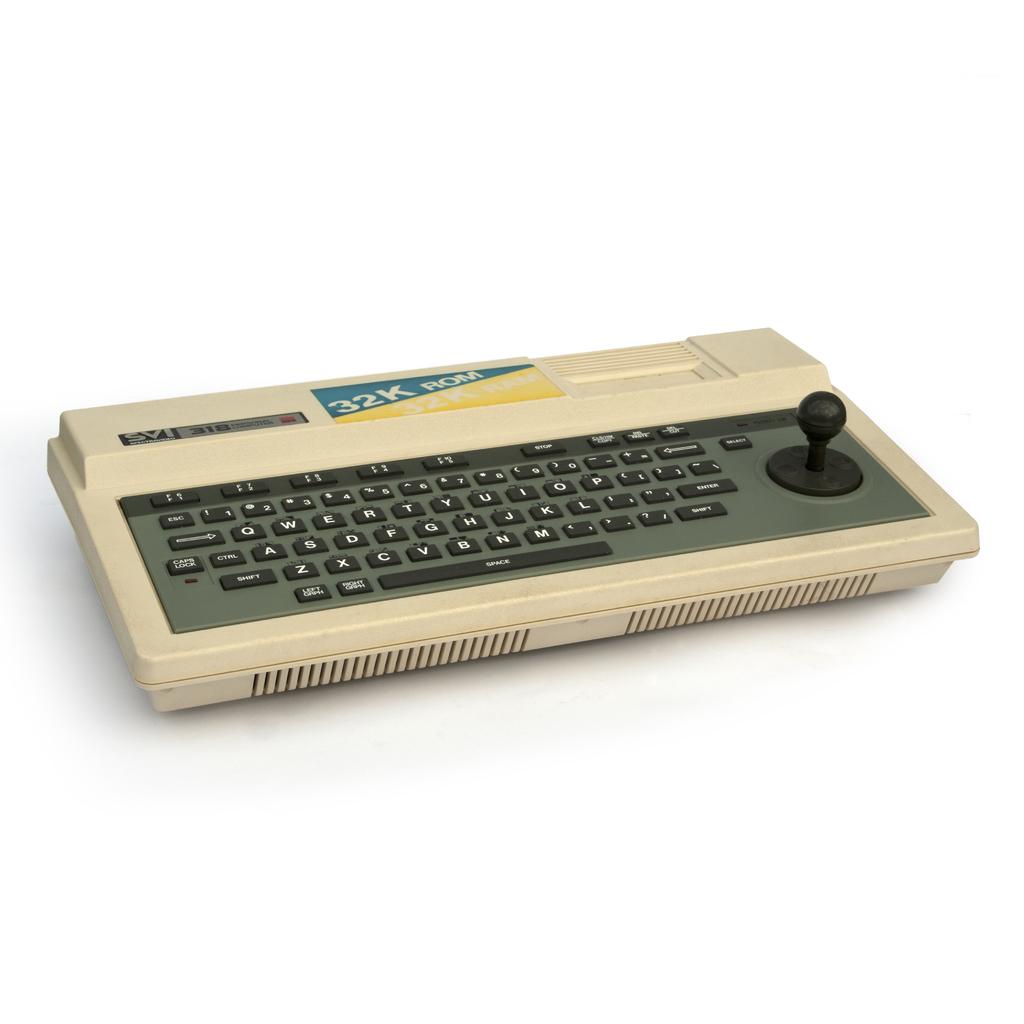What is listed before rom?
Make the answer very short. 32k. 